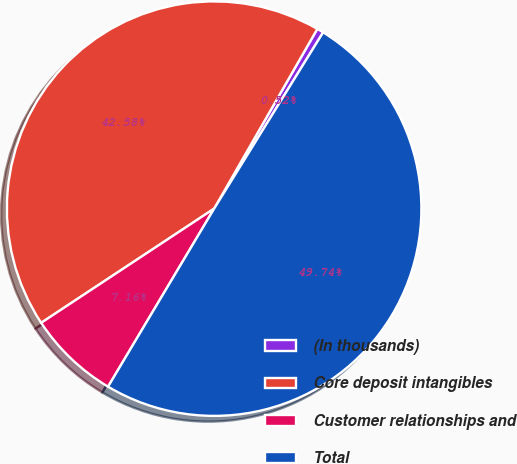Convert chart to OTSL. <chart><loc_0><loc_0><loc_500><loc_500><pie_chart><fcel>(In thousands)<fcel>Core deposit intangibles<fcel>Customer relationships and<fcel>Total<nl><fcel>0.52%<fcel>42.58%<fcel>7.16%<fcel>49.74%<nl></chart> 